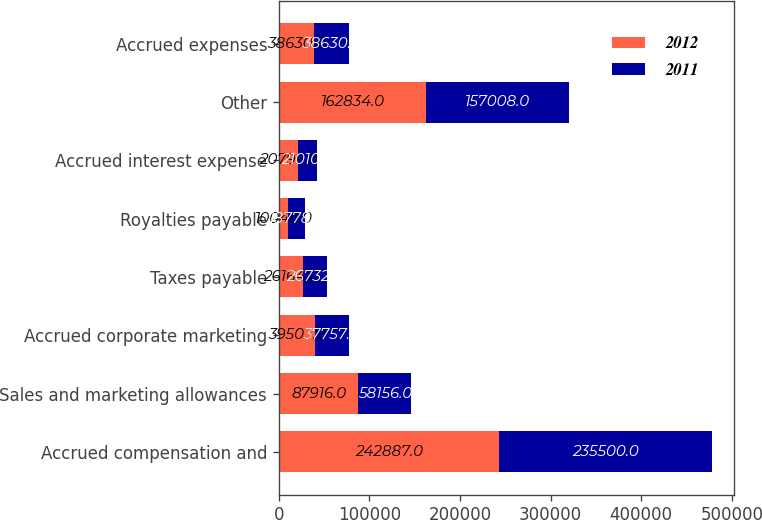Convert chart. <chart><loc_0><loc_0><loc_500><loc_500><stacked_bar_chart><ecel><fcel>Accrued compensation and<fcel>Sales and marketing allowances<fcel>Accrued corporate marketing<fcel>Taxes payable<fcel>Royalties payable<fcel>Accrued interest expense<fcel>Other<fcel>Accrued expenses<nl><fcel>2012<fcel>242887<fcel>87916<fcel>39503<fcel>26164<fcel>10040<fcel>20796<fcel>162834<fcel>38630<nl><fcel>2011<fcel>235500<fcel>58156<fcel>37757<fcel>26732<fcel>18778<fcel>21010<fcel>157008<fcel>38630<nl></chart> 